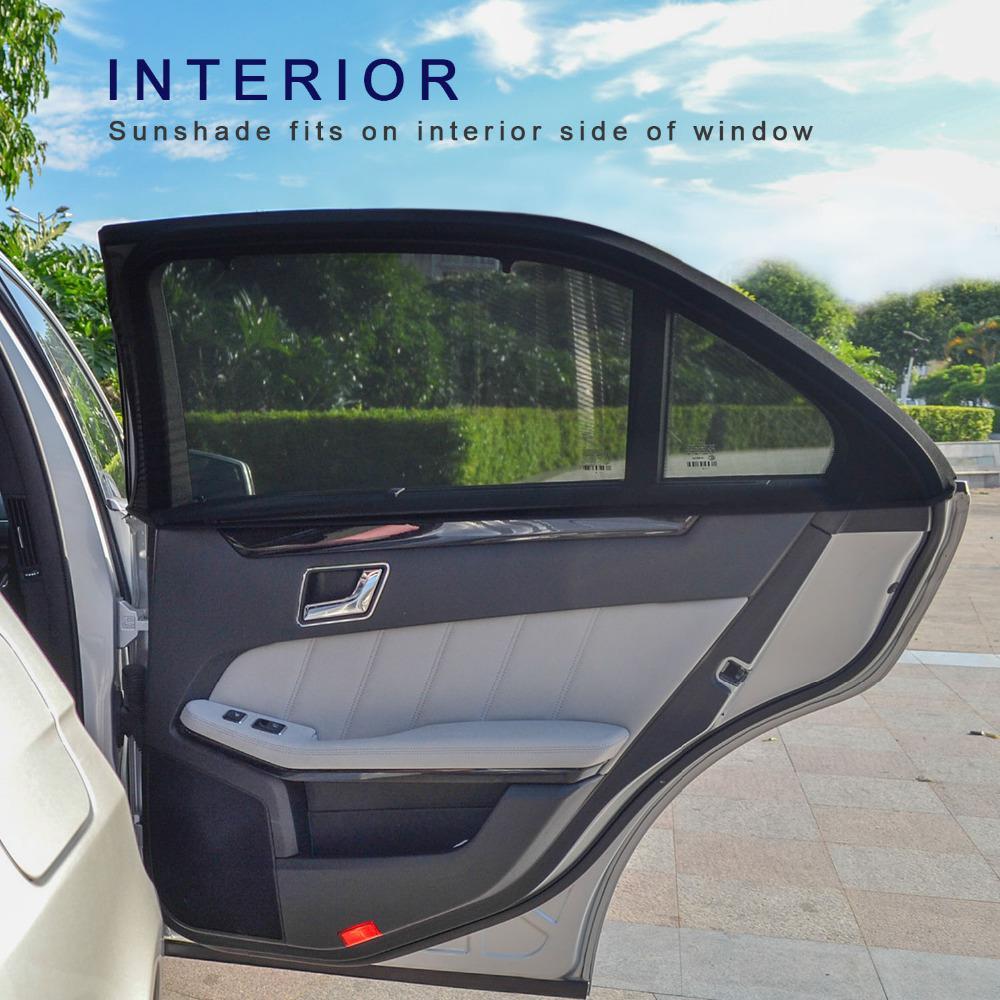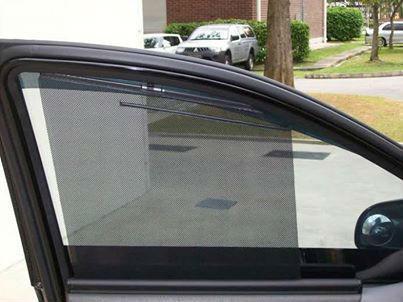The first image is the image on the left, the second image is the image on the right. Examine the images to the left and right. Is the description "In the left image the door is open and you can see a second car in the background." accurate? Answer yes or no. No. 